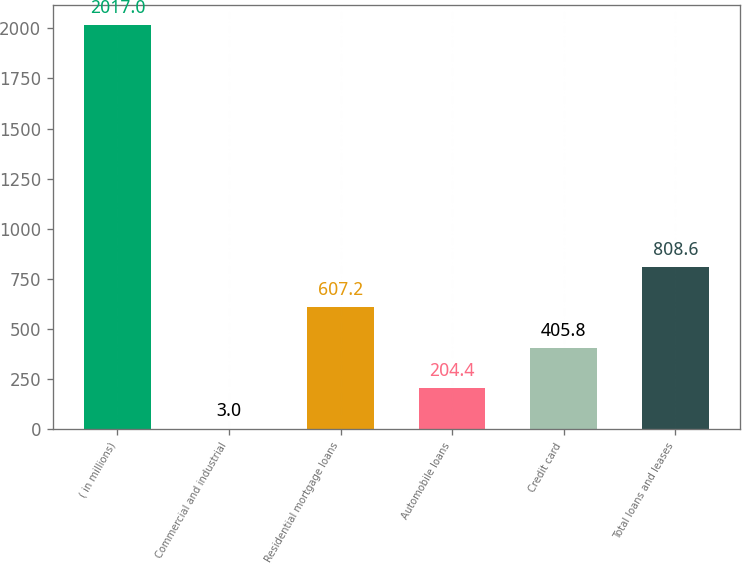Convert chart to OTSL. <chart><loc_0><loc_0><loc_500><loc_500><bar_chart><fcel>( in millions)<fcel>Commercial and industrial<fcel>Residential mortgage loans<fcel>Automobile loans<fcel>Credit card<fcel>Total loans and leases<nl><fcel>2017<fcel>3<fcel>607.2<fcel>204.4<fcel>405.8<fcel>808.6<nl></chart> 